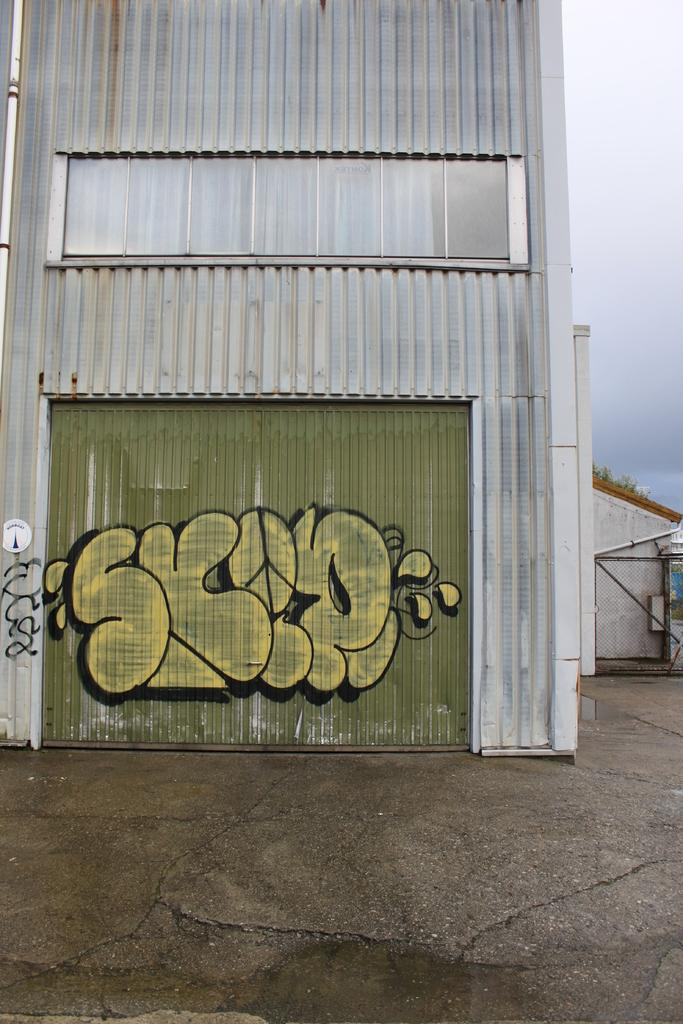What is the main structure in the image? There is a building in the image. What can be seen on the wall of the building? Something is painted on the wall of the building. What is visible in the background of the image? The sky is visible in the background of the image. Where is the train located in the image? There is no train present in the image. What type of drain is visible in the image? There is no drain present in the image. 